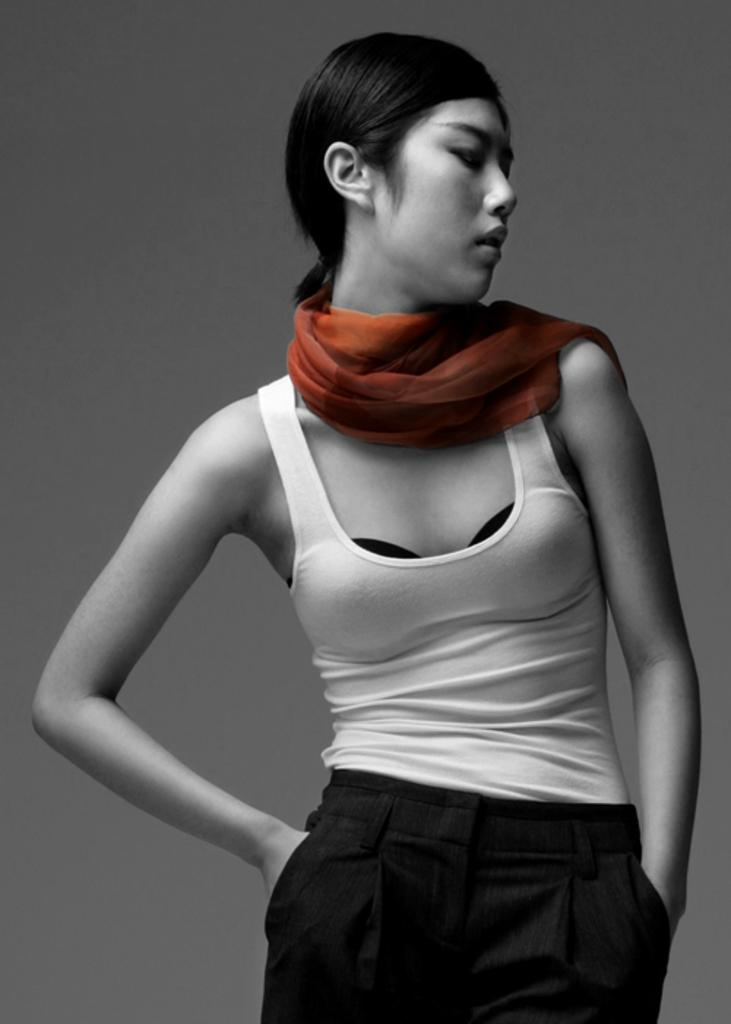What is the main subject of the picture? The main subject of the picture is a woman. What is the woman wearing on her upper body? The woman is wearing a white top. What is the woman wearing on her lower body? The woman is wearing a black pant. Is there any accessory visible on the woman's neck? Yes, there is a scarf on the woman's neck. What type of wave can be seen crashing on the shore in the image? There is no wave or shore present in the image; it features a woman wearing a white top, black pant, and a scarf on her neck. 